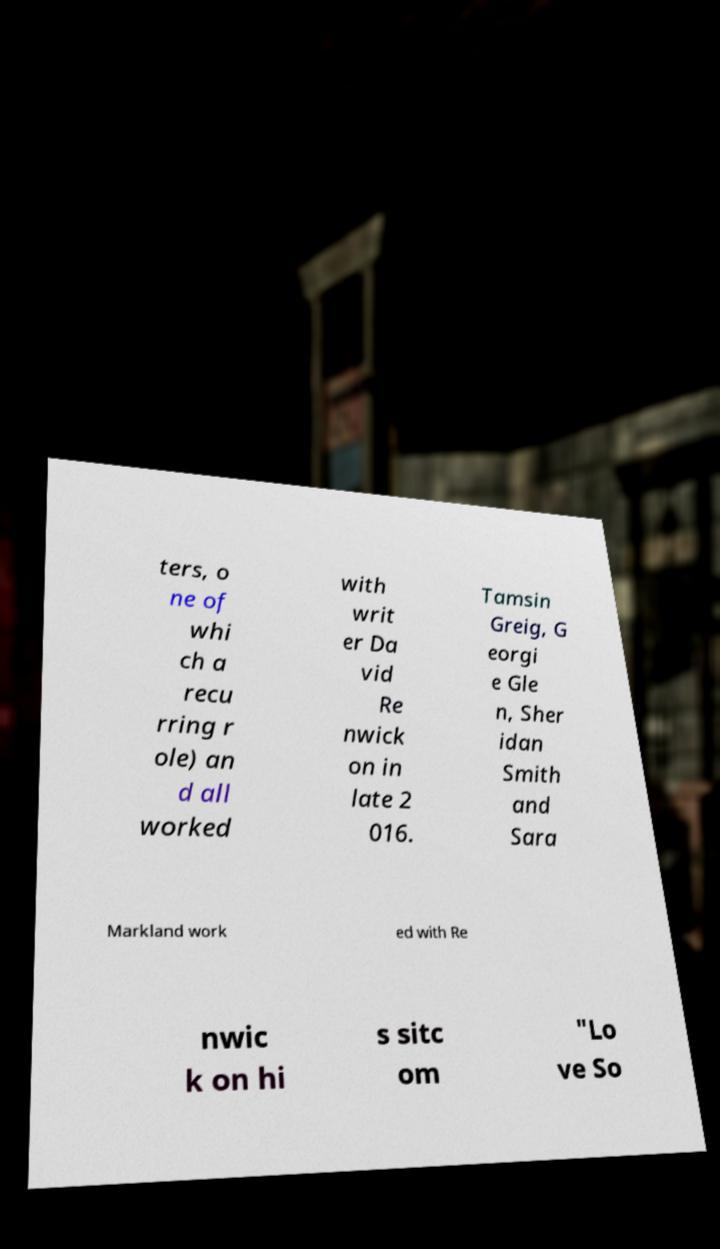Please read and relay the text visible in this image. What does it say? ters, o ne of whi ch a recu rring r ole) an d all worked with writ er Da vid Re nwick on in late 2 016. Tamsin Greig, G eorgi e Gle n, Sher idan Smith and Sara Markland work ed with Re nwic k on hi s sitc om "Lo ve So 